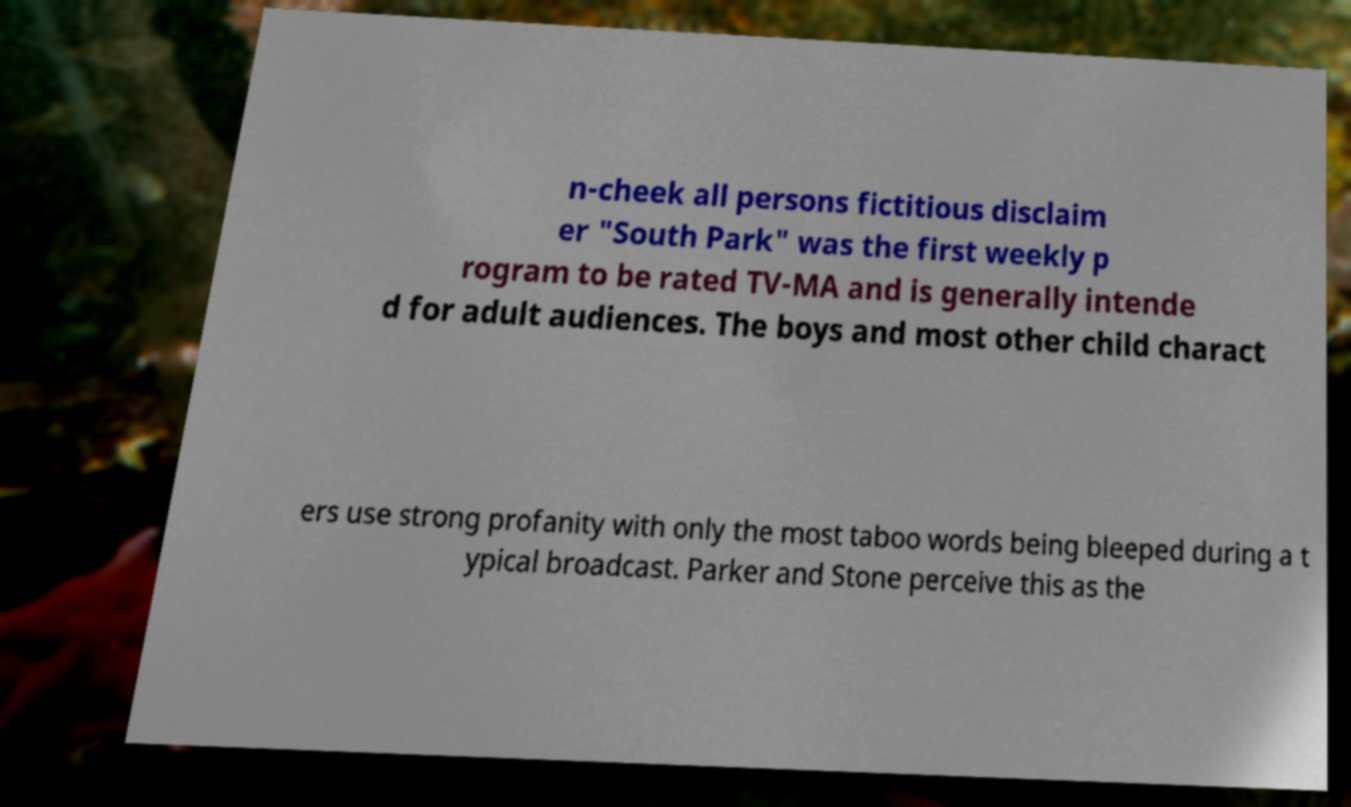Can you accurately transcribe the text from the provided image for me? n-cheek all persons fictitious disclaim er "South Park" was the first weekly p rogram to be rated TV-MA and is generally intende d for adult audiences. The boys and most other child charact ers use strong profanity with only the most taboo words being bleeped during a t ypical broadcast. Parker and Stone perceive this as the 